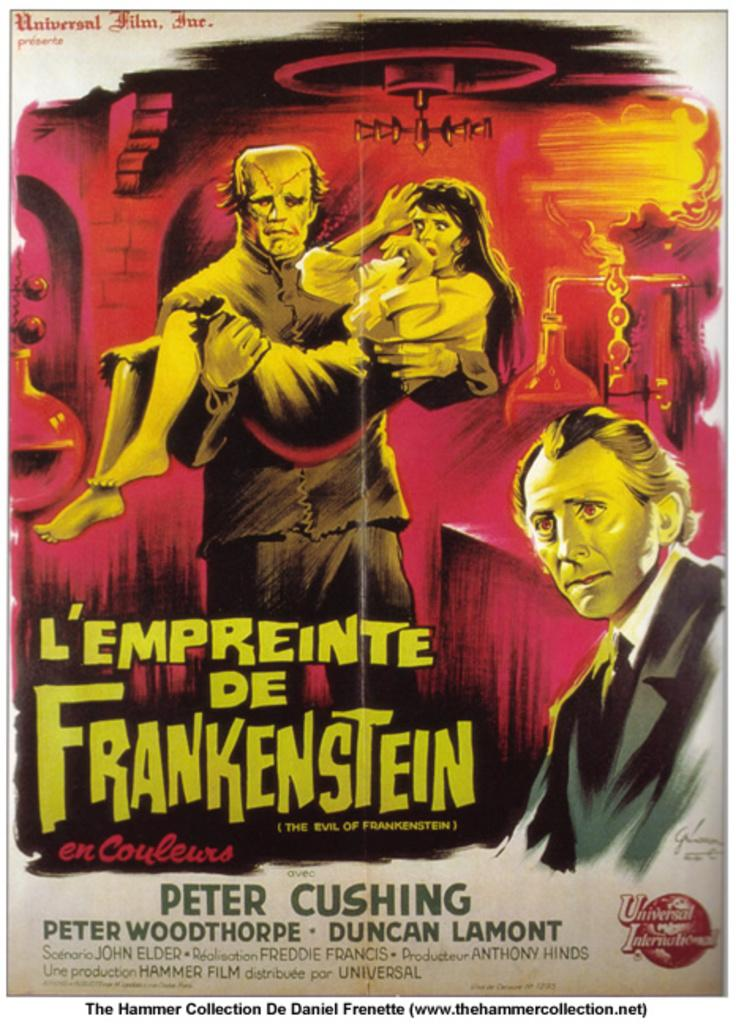<image>
Summarize the visual content of the image. a poster that says 'l'empreinte de frankenstein' on it 